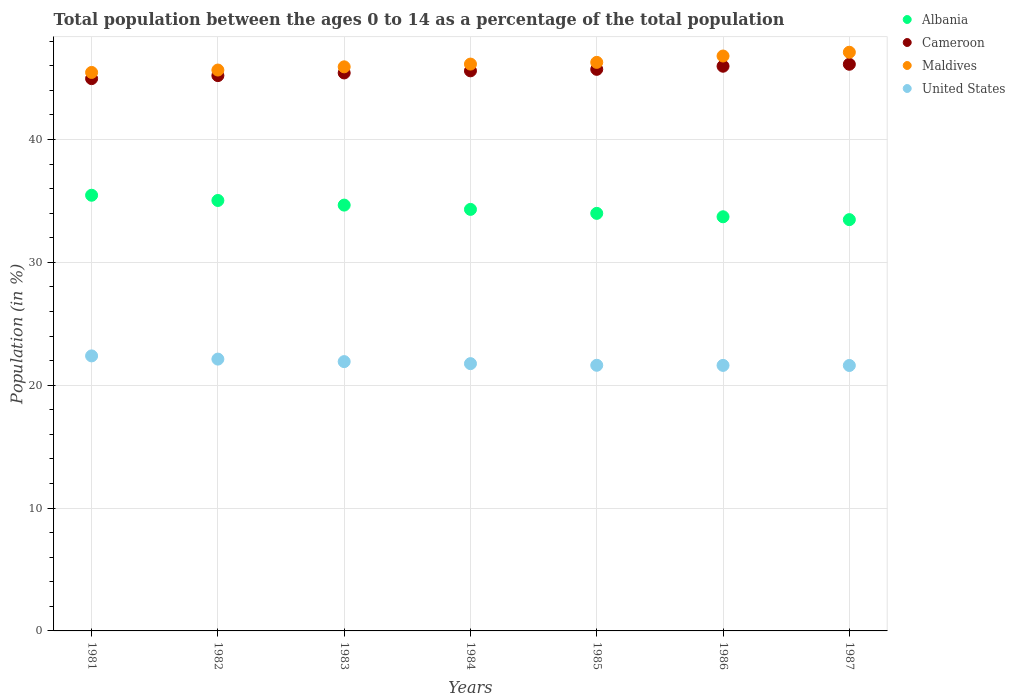Is the number of dotlines equal to the number of legend labels?
Your answer should be compact. Yes. What is the percentage of the population ages 0 to 14 in Maldives in 1986?
Make the answer very short. 46.79. Across all years, what is the maximum percentage of the population ages 0 to 14 in Albania?
Keep it short and to the point. 35.46. Across all years, what is the minimum percentage of the population ages 0 to 14 in United States?
Your answer should be very brief. 21.61. In which year was the percentage of the population ages 0 to 14 in Maldives maximum?
Make the answer very short. 1987. In which year was the percentage of the population ages 0 to 14 in Cameroon minimum?
Your answer should be very brief. 1981. What is the total percentage of the population ages 0 to 14 in Albania in the graph?
Make the answer very short. 240.64. What is the difference between the percentage of the population ages 0 to 14 in Maldives in 1981 and that in 1982?
Ensure brevity in your answer.  -0.2. What is the difference between the percentage of the population ages 0 to 14 in Cameroon in 1984 and the percentage of the population ages 0 to 14 in Maldives in 1986?
Keep it short and to the point. -1.21. What is the average percentage of the population ages 0 to 14 in Cameroon per year?
Your answer should be very brief. 45.57. In the year 1983, what is the difference between the percentage of the population ages 0 to 14 in United States and percentage of the population ages 0 to 14 in Cameroon?
Your response must be concise. -23.5. What is the ratio of the percentage of the population ages 0 to 14 in United States in 1983 to that in 1984?
Your answer should be compact. 1.01. Is the percentage of the population ages 0 to 14 in Maldives in 1983 less than that in 1986?
Give a very brief answer. Yes. What is the difference between the highest and the second highest percentage of the population ages 0 to 14 in United States?
Provide a short and direct response. 0.26. What is the difference between the highest and the lowest percentage of the population ages 0 to 14 in Albania?
Your response must be concise. 1.99. Is it the case that in every year, the sum of the percentage of the population ages 0 to 14 in Maldives and percentage of the population ages 0 to 14 in Albania  is greater than the percentage of the population ages 0 to 14 in Cameroon?
Your answer should be compact. Yes. Is the percentage of the population ages 0 to 14 in Albania strictly greater than the percentage of the population ages 0 to 14 in Maldives over the years?
Your answer should be compact. No. How many dotlines are there?
Provide a short and direct response. 4. How many years are there in the graph?
Provide a succinct answer. 7. What is the difference between two consecutive major ticks on the Y-axis?
Provide a succinct answer. 10. Does the graph contain any zero values?
Keep it short and to the point. No. Does the graph contain grids?
Make the answer very short. Yes. How are the legend labels stacked?
Your answer should be very brief. Vertical. What is the title of the graph?
Ensure brevity in your answer.  Total population between the ages 0 to 14 as a percentage of the total population. What is the label or title of the Y-axis?
Ensure brevity in your answer.  Population (in %). What is the Population (in %) in Albania in 1981?
Provide a short and direct response. 35.46. What is the Population (in %) of Cameroon in 1981?
Ensure brevity in your answer.  44.95. What is the Population (in %) of Maldives in 1981?
Provide a short and direct response. 45.46. What is the Population (in %) in United States in 1981?
Your answer should be very brief. 22.39. What is the Population (in %) in Albania in 1982?
Ensure brevity in your answer.  35.04. What is the Population (in %) of Cameroon in 1982?
Ensure brevity in your answer.  45.2. What is the Population (in %) in Maldives in 1982?
Give a very brief answer. 45.65. What is the Population (in %) in United States in 1982?
Make the answer very short. 22.13. What is the Population (in %) in Albania in 1983?
Offer a very short reply. 34.66. What is the Population (in %) in Cameroon in 1983?
Keep it short and to the point. 45.42. What is the Population (in %) in Maldives in 1983?
Keep it short and to the point. 45.92. What is the Population (in %) in United States in 1983?
Ensure brevity in your answer.  21.92. What is the Population (in %) in Albania in 1984?
Provide a succinct answer. 34.31. What is the Population (in %) in Cameroon in 1984?
Provide a short and direct response. 45.59. What is the Population (in %) in Maldives in 1984?
Your answer should be very brief. 46.14. What is the Population (in %) of United States in 1984?
Give a very brief answer. 21.76. What is the Population (in %) in Albania in 1985?
Provide a succinct answer. 33.99. What is the Population (in %) of Cameroon in 1985?
Your answer should be compact. 45.71. What is the Population (in %) of Maldives in 1985?
Your answer should be very brief. 46.28. What is the Population (in %) of United States in 1985?
Make the answer very short. 21.62. What is the Population (in %) in Albania in 1986?
Provide a succinct answer. 33.71. What is the Population (in %) of Cameroon in 1986?
Provide a succinct answer. 45.96. What is the Population (in %) in Maldives in 1986?
Provide a succinct answer. 46.79. What is the Population (in %) in United States in 1986?
Your answer should be very brief. 21.61. What is the Population (in %) in Albania in 1987?
Keep it short and to the point. 33.48. What is the Population (in %) of Cameroon in 1987?
Your response must be concise. 46.12. What is the Population (in %) in Maldives in 1987?
Your response must be concise. 47.1. What is the Population (in %) of United States in 1987?
Provide a short and direct response. 21.61. Across all years, what is the maximum Population (in %) in Albania?
Provide a succinct answer. 35.46. Across all years, what is the maximum Population (in %) of Cameroon?
Give a very brief answer. 46.12. Across all years, what is the maximum Population (in %) in Maldives?
Make the answer very short. 47.1. Across all years, what is the maximum Population (in %) in United States?
Your answer should be compact. 22.39. Across all years, what is the minimum Population (in %) of Albania?
Keep it short and to the point. 33.48. Across all years, what is the minimum Population (in %) of Cameroon?
Keep it short and to the point. 44.95. Across all years, what is the minimum Population (in %) of Maldives?
Keep it short and to the point. 45.46. Across all years, what is the minimum Population (in %) in United States?
Your answer should be very brief. 21.61. What is the total Population (in %) of Albania in the graph?
Offer a very short reply. 240.64. What is the total Population (in %) of Cameroon in the graph?
Your answer should be very brief. 318.96. What is the total Population (in %) in Maldives in the graph?
Ensure brevity in your answer.  323.34. What is the total Population (in %) of United States in the graph?
Give a very brief answer. 153.03. What is the difference between the Population (in %) in Albania in 1981 and that in 1982?
Keep it short and to the point. 0.43. What is the difference between the Population (in %) of Cameroon in 1981 and that in 1982?
Give a very brief answer. -0.25. What is the difference between the Population (in %) of Maldives in 1981 and that in 1982?
Provide a short and direct response. -0.2. What is the difference between the Population (in %) of United States in 1981 and that in 1982?
Offer a very short reply. 0.26. What is the difference between the Population (in %) in Albania in 1981 and that in 1983?
Give a very brief answer. 0.8. What is the difference between the Population (in %) in Cameroon in 1981 and that in 1983?
Make the answer very short. -0.46. What is the difference between the Population (in %) of Maldives in 1981 and that in 1983?
Your response must be concise. -0.46. What is the difference between the Population (in %) in United States in 1981 and that in 1983?
Offer a very short reply. 0.47. What is the difference between the Population (in %) of Albania in 1981 and that in 1984?
Your answer should be compact. 1.15. What is the difference between the Population (in %) of Cameroon in 1981 and that in 1984?
Ensure brevity in your answer.  -0.63. What is the difference between the Population (in %) of Maldives in 1981 and that in 1984?
Make the answer very short. -0.68. What is the difference between the Population (in %) in United States in 1981 and that in 1984?
Offer a terse response. 0.63. What is the difference between the Population (in %) of Albania in 1981 and that in 1985?
Your response must be concise. 1.47. What is the difference between the Population (in %) of Cameroon in 1981 and that in 1985?
Your answer should be compact. -0.76. What is the difference between the Population (in %) in Maldives in 1981 and that in 1985?
Give a very brief answer. -0.82. What is the difference between the Population (in %) in United States in 1981 and that in 1985?
Your answer should be compact. 0.76. What is the difference between the Population (in %) in Albania in 1981 and that in 1986?
Offer a terse response. 1.75. What is the difference between the Population (in %) of Cameroon in 1981 and that in 1986?
Keep it short and to the point. -1.01. What is the difference between the Population (in %) in Maldives in 1981 and that in 1986?
Your answer should be compact. -1.34. What is the difference between the Population (in %) of United States in 1981 and that in 1986?
Offer a very short reply. 0.77. What is the difference between the Population (in %) in Albania in 1981 and that in 1987?
Offer a terse response. 1.99. What is the difference between the Population (in %) of Cameroon in 1981 and that in 1987?
Offer a terse response. -1.17. What is the difference between the Population (in %) of Maldives in 1981 and that in 1987?
Your answer should be compact. -1.64. What is the difference between the Population (in %) of United States in 1981 and that in 1987?
Ensure brevity in your answer.  0.78. What is the difference between the Population (in %) of Albania in 1982 and that in 1983?
Your answer should be compact. 0.38. What is the difference between the Population (in %) of Cameroon in 1982 and that in 1983?
Keep it short and to the point. -0.22. What is the difference between the Population (in %) of Maldives in 1982 and that in 1983?
Make the answer very short. -0.26. What is the difference between the Population (in %) in United States in 1982 and that in 1983?
Make the answer very short. 0.2. What is the difference between the Population (in %) of Albania in 1982 and that in 1984?
Offer a very short reply. 0.73. What is the difference between the Population (in %) of Cameroon in 1982 and that in 1984?
Provide a succinct answer. -0.39. What is the difference between the Population (in %) of Maldives in 1982 and that in 1984?
Provide a short and direct response. -0.48. What is the difference between the Population (in %) of United States in 1982 and that in 1984?
Provide a short and direct response. 0.37. What is the difference between the Population (in %) of Albania in 1982 and that in 1985?
Offer a very short reply. 1.05. What is the difference between the Population (in %) in Cameroon in 1982 and that in 1985?
Your answer should be very brief. -0.51. What is the difference between the Population (in %) of Maldives in 1982 and that in 1985?
Your response must be concise. -0.63. What is the difference between the Population (in %) of United States in 1982 and that in 1985?
Your answer should be very brief. 0.5. What is the difference between the Population (in %) in Albania in 1982 and that in 1986?
Make the answer very short. 1.33. What is the difference between the Population (in %) in Cameroon in 1982 and that in 1986?
Offer a terse response. -0.76. What is the difference between the Population (in %) of Maldives in 1982 and that in 1986?
Ensure brevity in your answer.  -1.14. What is the difference between the Population (in %) in United States in 1982 and that in 1986?
Provide a succinct answer. 0.51. What is the difference between the Population (in %) of Albania in 1982 and that in 1987?
Ensure brevity in your answer.  1.56. What is the difference between the Population (in %) in Cameroon in 1982 and that in 1987?
Offer a very short reply. -0.92. What is the difference between the Population (in %) of Maldives in 1982 and that in 1987?
Provide a succinct answer. -1.45. What is the difference between the Population (in %) of United States in 1982 and that in 1987?
Your response must be concise. 0.52. What is the difference between the Population (in %) of Albania in 1983 and that in 1984?
Your answer should be compact. 0.35. What is the difference between the Population (in %) of Cameroon in 1983 and that in 1984?
Provide a short and direct response. -0.17. What is the difference between the Population (in %) in Maldives in 1983 and that in 1984?
Ensure brevity in your answer.  -0.22. What is the difference between the Population (in %) of United States in 1983 and that in 1984?
Provide a short and direct response. 0.16. What is the difference between the Population (in %) in Albania in 1983 and that in 1985?
Keep it short and to the point. 0.67. What is the difference between the Population (in %) in Cameroon in 1983 and that in 1985?
Offer a terse response. -0.29. What is the difference between the Population (in %) of Maldives in 1983 and that in 1985?
Ensure brevity in your answer.  -0.36. What is the difference between the Population (in %) in United States in 1983 and that in 1985?
Offer a terse response. 0.3. What is the difference between the Population (in %) in Albania in 1983 and that in 1986?
Your answer should be compact. 0.95. What is the difference between the Population (in %) of Cameroon in 1983 and that in 1986?
Your response must be concise. -0.55. What is the difference between the Population (in %) in Maldives in 1983 and that in 1986?
Offer a terse response. -0.88. What is the difference between the Population (in %) in United States in 1983 and that in 1986?
Keep it short and to the point. 0.31. What is the difference between the Population (in %) in Albania in 1983 and that in 1987?
Give a very brief answer. 1.18. What is the difference between the Population (in %) in Cameroon in 1983 and that in 1987?
Your answer should be compact. -0.71. What is the difference between the Population (in %) of Maldives in 1983 and that in 1987?
Make the answer very short. -1.19. What is the difference between the Population (in %) of United States in 1983 and that in 1987?
Provide a short and direct response. 0.31. What is the difference between the Population (in %) in Albania in 1984 and that in 1985?
Offer a very short reply. 0.32. What is the difference between the Population (in %) of Cameroon in 1984 and that in 1985?
Your answer should be very brief. -0.12. What is the difference between the Population (in %) of Maldives in 1984 and that in 1985?
Your response must be concise. -0.14. What is the difference between the Population (in %) of United States in 1984 and that in 1985?
Keep it short and to the point. 0.13. What is the difference between the Population (in %) in Albania in 1984 and that in 1986?
Ensure brevity in your answer.  0.6. What is the difference between the Population (in %) in Cameroon in 1984 and that in 1986?
Your answer should be compact. -0.38. What is the difference between the Population (in %) of Maldives in 1984 and that in 1986?
Give a very brief answer. -0.66. What is the difference between the Population (in %) of United States in 1984 and that in 1986?
Your response must be concise. 0.14. What is the difference between the Population (in %) of Albania in 1984 and that in 1987?
Your response must be concise. 0.83. What is the difference between the Population (in %) in Cameroon in 1984 and that in 1987?
Keep it short and to the point. -0.54. What is the difference between the Population (in %) of Maldives in 1984 and that in 1987?
Offer a terse response. -0.96. What is the difference between the Population (in %) of United States in 1984 and that in 1987?
Offer a terse response. 0.15. What is the difference between the Population (in %) of Albania in 1985 and that in 1986?
Your answer should be compact. 0.28. What is the difference between the Population (in %) in Cameroon in 1985 and that in 1986?
Offer a terse response. -0.25. What is the difference between the Population (in %) in Maldives in 1985 and that in 1986?
Your answer should be compact. -0.52. What is the difference between the Population (in %) of United States in 1985 and that in 1986?
Your answer should be very brief. 0.01. What is the difference between the Population (in %) of Albania in 1985 and that in 1987?
Give a very brief answer. 0.51. What is the difference between the Population (in %) of Cameroon in 1985 and that in 1987?
Your answer should be very brief. -0.41. What is the difference between the Population (in %) in Maldives in 1985 and that in 1987?
Your answer should be compact. -0.82. What is the difference between the Population (in %) in United States in 1985 and that in 1987?
Provide a succinct answer. 0.02. What is the difference between the Population (in %) of Albania in 1986 and that in 1987?
Offer a very short reply. 0.23. What is the difference between the Population (in %) in Cameroon in 1986 and that in 1987?
Offer a very short reply. -0.16. What is the difference between the Population (in %) of Maldives in 1986 and that in 1987?
Offer a very short reply. -0.31. What is the difference between the Population (in %) of United States in 1986 and that in 1987?
Keep it short and to the point. 0.01. What is the difference between the Population (in %) of Albania in 1981 and the Population (in %) of Cameroon in 1982?
Offer a very short reply. -9.74. What is the difference between the Population (in %) in Albania in 1981 and the Population (in %) in Maldives in 1982?
Give a very brief answer. -10.19. What is the difference between the Population (in %) in Albania in 1981 and the Population (in %) in United States in 1982?
Your response must be concise. 13.34. What is the difference between the Population (in %) in Cameroon in 1981 and the Population (in %) in Maldives in 1982?
Your answer should be compact. -0.7. What is the difference between the Population (in %) of Cameroon in 1981 and the Population (in %) of United States in 1982?
Your answer should be compact. 22.83. What is the difference between the Population (in %) in Maldives in 1981 and the Population (in %) in United States in 1982?
Offer a very short reply. 23.33. What is the difference between the Population (in %) in Albania in 1981 and the Population (in %) in Cameroon in 1983?
Provide a short and direct response. -9.95. What is the difference between the Population (in %) in Albania in 1981 and the Population (in %) in Maldives in 1983?
Provide a succinct answer. -10.45. What is the difference between the Population (in %) in Albania in 1981 and the Population (in %) in United States in 1983?
Keep it short and to the point. 13.54. What is the difference between the Population (in %) in Cameroon in 1981 and the Population (in %) in Maldives in 1983?
Offer a terse response. -0.96. What is the difference between the Population (in %) in Cameroon in 1981 and the Population (in %) in United States in 1983?
Offer a terse response. 23.03. What is the difference between the Population (in %) of Maldives in 1981 and the Population (in %) of United States in 1983?
Provide a succinct answer. 23.54. What is the difference between the Population (in %) in Albania in 1981 and the Population (in %) in Cameroon in 1984?
Give a very brief answer. -10.13. What is the difference between the Population (in %) in Albania in 1981 and the Population (in %) in Maldives in 1984?
Offer a very short reply. -10.68. What is the difference between the Population (in %) in Albania in 1981 and the Population (in %) in United States in 1984?
Give a very brief answer. 13.71. What is the difference between the Population (in %) of Cameroon in 1981 and the Population (in %) of Maldives in 1984?
Provide a succinct answer. -1.18. What is the difference between the Population (in %) of Cameroon in 1981 and the Population (in %) of United States in 1984?
Your answer should be compact. 23.2. What is the difference between the Population (in %) of Maldives in 1981 and the Population (in %) of United States in 1984?
Keep it short and to the point. 23.7. What is the difference between the Population (in %) in Albania in 1981 and the Population (in %) in Cameroon in 1985?
Provide a succinct answer. -10.25. What is the difference between the Population (in %) of Albania in 1981 and the Population (in %) of Maldives in 1985?
Your response must be concise. -10.82. What is the difference between the Population (in %) in Albania in 1981 and the Population (in %) in United States in 1985?
Provide a succinct answer. 13.84. What is the difference between the Population (in %) of Cameroon in 1981 and the Population (in %) of Maldives in 1985?
Offer a terse response. -1.32. What is the difference between the Population (in %) of Cameroon in 1981 and the Population (in %) of United States in 1985?
Provide a succinct answer. 23.33. What is the difference between the Population (in %) in Maldives in 1981 and the Population (in %) in United States in 1985?
Ensure brevity in your answer.  23.84. What is the difference between the Population (in %) in Albania in 1981 and the Population (in %) in Cameroon in 1986?
Offer a terse response. -10.5. What is the difference between the Population (in %) of Albania in 1981 and the Population (in %) of Maldives in 1986?
Offer a very short reply. -11.33. What is the difference between the Population (in %) of Albania in 1981 and the Population (in %) of United States in 1986?
Ensure brevity in your answer.  13.85. What is the difference between the Population (in %) in Cameroon in 1981 and the Population (in %) in Maldives in 1986?
Offer a very short reply. -1.84. What is the difference between the Population (in %) of Cameroon in 1981 and the Population (in %) of United States in 1986?
Provide a succinct answer. 23.34. What is the difference between the Population (in %) in Maldives in 1981 and the Population (in %) in United States in 1986?
Your response must be concise. 23.85. What is the difference between the Population (in %) of Albania in 1981 and the Population (in %) of Cameroon in 1987?
Make the answer very short. -10.66. What is the difference between the Population (in %) in Albania in 1981 and the Population (in %) in Maldives in 1987?
Your response must be concise. -11.64. What is the difference between the Population (in %) of Albania in 1981 and the Population (in %) of United States in 1987?
Your answer should be compact. 13.86. What is the difference between the Population (in %) in Cameroon in 1981 and the Population (in %) in Maldives in 1987?
Make the answer very short. -2.15. What is the difference between the Population (in %) of Cameroon in 1981 and the Population (in %) of United States in 1987?
Keep it short and to the point. 23.35. What is the difference between the Population (in %) in Maldives in 1981 and the Population (in %) in United States in 1987?
Give a very brief answer. 23.85. What is the difference between the Population (in %) in Albania in 1982 and the Population (in %) in Cameroon in 1983?
Provide a short and direct response. -10.38. What is the difference between the Population (in %) of Albania in 1982 and the Population (in %) of Maldives in 1983?
Give a very brief answer. -10.88. What is the difference between the Population (in %) in Albania in 1982 and the Population (in %) in United States in 1983?
Provide a short and direct response. 13.12. What is the difference between the Population (in %) of Cameroon in 1982 and the Population (in %) of Maldives in 1983?
Offer a terse response. -0.71. What is the difference between the Population (in %) of Cameroon in 1982 and the Population (in %) of United States in 1983?
Ensure brevity in your answer.  23.28. What is the difference between the Population (in %) in Maldives in 1982 and the Population (in %) in United States in 1983?
Provide a succinct answer. 23.73. What is the difference between the Population (in %) in Albania in 1982 and the Population (in %) in Cameroon in 1984?
Provide a short and direct response. -10.55. What is the difference between the Population (in %) in Albania in 1982 and the Population (in %) in Maldives in 1984?
Offer a very short reply. -11.1. What is the difference between the Population (in %) of Albania in 1982 and the Population (in %) of United States in 1984?
Provide a succinct answer. 13.28. What is the difference between the Population (in %) in Cameroon in 1982 and the Population (in %) in Maldives in 1984?
Provide a short and direct response. -0.94. What is the difference between the Population (in %) in Cameroon in 1982 and the Population (in %) in United States in 1984?
Provide a succinct answer. 23.44. What is the difference between the Population (in %) of Maldives in 1982 and the Population (in %) of United States in 1984?
Make the answer very short. 23.9. What is the difference between the Population (in %) of Albania in 1982 and the Population (in %) of Cameroon in 1985?
Your response must be concise. -10.67. What is the difference between the Population (in %) in Albania in 1982 and the Population (in %) in Maldives in 1985?
Your response must be concise. -11.24. What is the difference between the Population (in %) in Albania in 1982 and the Population (in %) in United States in 1985?
Provide a succinct answer. 13.41. What is the difference between the Population (in %) in Cameroon in 1982 and the Population (in %) in Maldives in 1985?
Your answer should be compact. -1.08. What is the difference between the Population (in %) of Cameroon in 1982 and the Population (in %) of United States in 1985?
Provide a short and direct response. 23.58. What is the difference between the Population (in %) of Maldives in 1982 and the Population (in %) of United States in 1985?
Offer a very short reply. 24.03. What is the difference between the Population (in %) of Albania in 1982 and the Population (in %) of Cameroon in 1986?
Offer a terse response. -10.93. What is the difference between the Population (in %) of Albania in 1982 and the Population (in %) of Maldives in 1986?
Your response must be concise. -11.76. What is the difference between the Population (in %) of Albania in 1982 and the Population (in %) of United States in 1986?
Ensure brevity in your answer.  13.42. What is the difference between the Population (in %) in Cameroon in 1982 and the Population (in %) in Maldives in 1986?
Offer a terse response. -1.59. What is the difference between the Population (in %) of Cameroon in 1982 and the Population (in %) of United States in 1986?
Keep it short and to the point. 23.59. What is the difference between the Population (in %) of Maldives in 1982 and the Population (in %) of United States in 1986?
Offer a very short reply. 24.04. What is the difference between the Population (in %) in Albania in 1982 and the Population (in %) in Cameroon in 1987?
Ensure brevity in your answer.  -11.09. What is the difference between the Population (in %) of Albania in 1982 and the Population (in %) of Maldives in 1987?
Make the answer very short. -12.07. What is the difference between the Population (in %) in Albania in 1982 and the Population (in %) in United States in 1987?
Your answer should be compact. 13.43. What is the difference between the Population (in %) of Cameroon in 1982 and the Population (in %) of Maldives in 1987?
Your answer should be compact. -1.9. What is the difference between the Population (in %) in Cameroon in 1982 and the Population (in %) in United States in 1987?
Offer a very short reply. 23.59. What is the difference between the Population (in %) of Maldives in 1982 and the Population (in %) of United States in 1987?
Your answer should be compact. 24.05. What is the difference between the Population (in %) of Albania in 1983 and the Population (in %) of Cameroon in 1984?
Provide a short and direct response. -10.93. What is the difference between the Population (in %) in Albania in 1983 and the Population (in %) in Maldives in 1984?
Provide a short and direct response. -11.48. What is the difference between the Population (in %) in Albania in 1983 and the Population (in %) in United States in 1984?
Give a very brief answer. 12.9. What is the difference between the Population (in %) of Cameroon in 1983 and the Population (in %) of Maldives in 1984?
Make the answer very short. -0.72. What is the difference between the Population (in %) in Cameroon in 1983 and the Population (in %) in United States in 1984?
Ensure brevity in your answer.  23.66. What is the difference between the Population (in %) in Maldives in 1983 and the Population (in %) in United States in 1984?
Keep it short and to the point. 24.16. What is the difference between the Population (in %) in Albania in 1983 and the Population (in %) in Cameroon in 1985?
Offer a very short reply. -11.05. What is the difference between the Population (in %) in Albania in 1983 and the Population (in %) in Maldives in 1985?
Provide a succinct answer. -11.62. What is the difference between the Population (in %) of Albania in 1983 and the Population (in %) of United States in 1985?
Your response must be concise. 13.04. What is the difference between the Population (in %) of Cameroon in 1983 and the Population (in %) of Maldives in 1985?
Your answer should be compact. -0.86. What is the difference between the Population (in %) in Cameroon in 1983 and the Population (in %) in United States in 1985?
Provide a short and direct response. 23.79. What is the difference between the Population (in %) in Maldives in 1983 and the Population (in %) in United States in 1985?
Offer a terse response. 24.29. What is the difference between the Population (in %) in Albania in 1983 and the Population (in %) in Cameroon in 1986?
Give a very brief answer. -11.3. What is the difference between the Population (in %) in Albania in 1983 and the Population (in %) in Maldives in 1986?
Offer a very short reply. -12.13. What is the difference between the Population (in %) of Albania in 1983 and the Population (in %) of United States in 1986?
Make the answer very short. 13.05. What is the difference between the Population (in %) in Cameroon in 1983 and the Population (in %) in Maldives in 1986?
Ensure brevity in your answer.  -1.38. What is the difference between the Population (in %) of Cameroon in 1983 and the Population (in %) of United States in 1986?
Give a very brief answer. 23.8. What is the difference between the Population (in %) of Maldives in 1983 and the Population (in %) of United States in 1986?
Keep it short and to the point. 24.3. What is the difference between the Population (in %) of Albania in 1983 and the Population (in %) of Cameroon in 1987?
Provide a succinct answer. -11.46. What is the difference between the Population (in %) of Albania in 1983 and the Population (in %) of Maldives in 1987?
Make the answer very short. -12.44. What is the difference between the Population (in %) of Albania in 1983 and the Population (in %) of United States in 1987?
Your answer should be compact. 13.05. What is the difference between the Population (in %) in Cameroon in 1983 and the Population (in %) in Maldives in 1987?
Provide a succinct answer. -1.69. What is the difference between the Population (in %) in Cameroon in 1983 and the Population (in %) in United States in 1987?
Ensure brevity in your answer.  23.81. What is the difference between the Population (in %) of Maldives in 1983 and the Population (in %) of United States in 1987?
Provide a succinct answer. 24.31. What is the difference between the Population (in %) in Albania in 1984 and the Population (in %) in Cameroon in 1985?
Your response must be concise. -11.4. What is the difference between the Population (in %) of Albania in 1984 and the Population (in %) of Maldives in 1985?
Your answer should be compact. -11.97. What is the difference between the Population (in %) in Albania in 1984 and the Population (in %) in United States in 1985?
Give a very brief answer. 12.69. What is the difference between the Population (in %) in Cameroon in 1984 and the Population (in %) in Maldives in 1985?
Ensure brevity in your answer.  -0.69. What is the difference between the Population (in %) of Cameroon in 1984 and the Population (in %) of United States in 1985?
Your response must be concise. 23.97. What is the difference between the Population (in %) in Maldives in 1984 and the Population (in %) in United States in 1985?
Ensure brevity in your answer.  24.52. What is the difference between the Population (in %) in Albania in 1984 and the Population (in %) in Cameroon in 1986?
Your answer should be very brief. -11.65. What is the difference between the Population (in %) of Albania in 1984 and the Population (in %) of Maldives in 1986?
Ensure brevity in your answer.  -12.48. What is the difference between the Population (in %) in Albania in 1984 and the Population (in %) in United States in 1986?
Make the answer very short. 12.7. What is the difference between the Population (in %) in Cameroon in 1984 and the Population (in %) in Maldives in 1986?
Provide a succinct answer. -1.21. What is the difference between the Population (in %) in Cameroon in 1984 and the Population (in %) in United States in 1986?
Keep it short and to the point. 23.98. What is the difference between the Population (in %) of Maldives in 1984 and the Population (in %) of United States in 1986?
Give a very brief answer. 24.52. What is the difference between the Population (in %) of Albania in 1984 and the Population (in %) of Cameroon in 1987?
Your answer should be very brief. -11.81. What is the difference between the Population (in %) of Albania in 1984 and the Population (in %) of Maldives in 1987?
Your answer should be compact. -12.79. What is the difference between the Population (in %) in Albania in 1984 and the Population (in %) in United States in 1987?
Give a very brief answer. 12.7. What is the difference between the Population (in %) of Cameroon in 1984 and the Population (in %) of Maldives in 1987?
Provide a succinct answer. -1.51. What is the difference between the Population (in %) of Cameroon in 1984 and the Population (in %) of United States in 1987?
Provide a short and direct response. 23.98. What is the difference between the Population (in %) in Maldives in 1984 and the Population (in %) in United States in 1987?
Your answer should be compact. 24.53. What is the difference between the Population (in %) of Albania in 1985 and the Population (in %) of Cameroon in 1986?
Make the answer very short. -11.98. What is the difference between the Population (in %) in Albania in 1985 and the Population (in %) in Maldives in 1986?
Your answer should be compact. -12.81. What is the difference between the Population (in %) in Albania in 1985 and the Population (in %) in United States in 1986?
Offer a very short reply. 12.37. What is the difference between the Population (in %) of Cameroon in 1985 and the Population (in %) of Maldives in 1986?
Your answer should be very brief. -1.08. What is the difference between the Population (in %) in Cameroon in 1985 and the Population (in %) in United States in 1986?
Offer a terse response. 24.1. What is the difference between the Population (in %) in Maldives in 1985 and the Population (in %) in United States in 1986?
Make the answer very short. 24.67. What is the difference between the Population (in %) of Albania in 1985 and the Population (in %) of Cameroon in 1987?
Offer a terse response. -12.14. What is the difference between the Population (in %) in Albania in 1985 and the Population (in %) in Maldives in 1987?
Offer a very short reply. -13.12. What is the difference between the Population (in %) in Albania in 1985 and the Population (in %) in United States in 1987?
Keep it short and to the point. 12.38. What is the difference between the Population (in %) of Cameroon in 1985 and the Population (in %) of Maldives in 1987?
Ensure brevity in your answer.  -1.39. What is the difference between the Population (in %) in Cameroon in 1985 and the Population (in %) in United States in 1987?
Provide a short and direct response. 24.1. What is the difference between the Population (in %) of Maldives in 1985 and the Population (in %) of United States in 1987?
Your answer should be compact. 24.67. What is the difference between the Population (in %) of Albania in 1986 and the Population (in %) of Cameroon in 1987?
Keep it short and to the point. -12.41. What is the difference between the Population (in %) in Albania in 1986 and the Population (in %) in Maldives in 1987?
Ensure brevity in your answer.  -13.39. What is the difference between the Population (in %) in Albania in 1986 and the Population (in %) in United States in 1987?
Your answer should be compact. 12.1. What is the difference between the Population (in %) of Cameroon in 1986 and the Population (in %) of Maldives in 1987?
Offer a terse response. -1.14. What is the difference between the Population (in %) of Cameroon in 1986 and the Population (in %) of United States in 1987?
Offer a terse response. 24.36. What is the difference between the Population (in %) of Maldives in 1986 and the Population (in %) of United States in 1987?
Your answer should be very brief. 25.19. What is the average Population (in %) of Albania per year?
Make the answer very short. 34.38. What is the average Population (in %) of Cameroon per year?
Ensure brevity in your answer.  45.57. What is the average Population (in %) of Maldives per year?
Your answer should be compact. 46.19. What is the average Population (in %) of United States per year?
Provide a short and direct response. 21.86. In the year 1981, what is the difference between the Population (in %) in Albania and Population (in %) in Cameroon?
Offer a terse response. -9.49. In the year 1981, what is the difference between the Population (in %) in Albania and Population (in %) in Maldives?
Offer a very short reply. -10. In the year 1981, what is the difference between the Population (in %) in Albania and Population (in %) in United States?
Your answer should be very brief. 13.08. In the year 1981, what is the difference between the Population (in %) in Cameroon and Population (in %) in Maldives?
Give a very brief answer. -0.5. In the year 1981, what is the difference between the Population (in %) in Cameroon and Population (in %) in United States?
Offer a terse response. 22.57. In the year 1981, what is the difference between the Population (in %) of Maldives and Population (in %) of United States?
Offer a very short reply. 23.07. In the year 1982, what is the difference between the Population (in %) of Albania and Population (in %) of Cameroon?
Your answer should be very brief. -10.16. In the year 1982, what is the difference between the Population (in %) of Albania and Population (in %) of Maldives?
Your response must be concise. -10.62. In the year 1982, what is the difference between the Population (in %) of Albania and Population (in %) of United States?
Ensure brevity in your answer.  12.91. In the year 1982, what is the difference between the Population (in %) in Cameroon and Population (in %) in Maldives?
Your answer should be compact. -0.45. In the year 1982, what is the difference between the Population (in %) of Cameroon and Population (in %) of United States?
Your answer should be very brief. 23.08. In the year 1982, what is the difference between the Population (in %) of Maldives and Population (in %) of United States?
Offer a very short reply. 23.53. In the year 1983, what is the difference between the Population (in %) in Albania and Population (in %) in Cameroon?
Offer a very short reply. -10.76. In the year 1983, what is the difference between the Population (in %) in Albania and Population (in %) in Maldives?
Keep it short and to the point. -11.26. In the year 1983, what is the difference between the Population (in %) of Albania and Population (in %) of United States?
Your response must be concise. 12.74. In the year 1983, what is the difference between the Population (in %) of Cameroon and Population (in %) of Maldives?
Offer a very short reply. -0.5. In the year 1983, what is the difference between the Population (in %) in Cameroon and Population (in %) in United States?
Your response must be concise. 23.5. In the year 1983, what is the difference between the Population (in %) in Maldives and Population (in %) in United States?
Ensure brevity in your answer.  23.99. In the year 1984, what is the difference between the Population (in %) in Albania and Population (in %) in Cameroon?
Your answer should be compact. -11.28. In the year 1984, what is the difference between the Population (in %) in Albania and Population (in %) in Maldives?
Your answer should be compact. -11.83. In the year 1984, what is the difference between the Population (in %) of Albania and Population (in %) of United States?
Keep it short and to the point. 12.56. In the year 1984, what is the difference between the Population (in %) of Cameroon and Population (in %) of Maldives?
Your answer should be compact. -0.55. In the year 1984, what is the difference between the Population (in %) of Cameroon and Population (in %) of United States?
Offer a terse response. 23.83. In the year 1984, what is the difference between the Population (in %) of Maldives and Population (in %) of United States?
Provide a succinct answer. 24.38. In the year 1985, what is the difference between the Population (in %) in Albania and Population (in %) in Cameroon?
Offer a very short reply. -11.72. In the year 1985, what is the difference between the Population (in %) of Albania and Population (in %) of Maldives?
Keep it short and to the point. -12.29. In the year 1985, what is the difference between the Population (in %) in Albania and Population (in %) in United States?
Your answer should be compact. 12.37. In the year 1985, what is the difference between the Population (in %) in Cameroon and Population (in %) in Maldives?
Offer a terse response. -0.57. In the year 1985, what is the difference between the Population (in %) of Cameroon and Population (in %) of United States?
Your response must be concise. 24.09. In the year 1985, what is the difference between the Population (in %) of Maldives and Population (in %) of United States?
Your answer should be very brief. 24.66. In the year 1986, what is the difference between the Population (in %) of Albania and Population (in %) of Cameroon?
Your answer should be compact. -12.25. In the year 1986, what is the difference between the Population (in %) in Albania and Population (in %) in Maldives?
Your answer should be very brief. -13.08. In the year 1986, what is the difference between the Population (in %) in Albania and Population (in %) in United States?
Your answer should be very brief. 12.1. In the year 1986, what is the difference between the Population (in %) of Cameroon and Population (in %) of Maldives?
Provide a succinct answer. -0.83. In the year 1986, what is the difference between the Population (in %) in Cameroon and Population (in %) in United States?
Provide a short and direct response. 24.35. In the year 1986, what is the difference between the Population (in %) of Maldives and Population (in %) of United States?
Your answer should be very brief. 25.18. In the year 1987, what is the difference between the Population (in %) in Albania and Population (in %) in Cameroon?
Keep it short and to the point. -12.65. In the year 1987, what is the difference between the Population (in %) of Albania and Population (in %) of Maldives?
Offer a very short reply. -13.63. In the year 1987, what is the difference between the Population (in %) in Albania and Population (in %) in United States?
Give a very brief answer. 11.87. In the year 1987, what is the difference between the Population (in %) in Cameroon and Population (in %) in Maldives?
Give a very brief answer. -0.98. In the year 1987, what is the difference between the Population (in %) in Cameroon and Population (in %) in United States?
Offer a very short reply. 24.52. In the year 1987, what is the difference between the Population (in %) in Maldives and Population (in %) in United States?
Provide a short and direct response. 25.5. What is the ratio of the Population (in %) of Albania in 1981 to that in 1982?
Offer a very short reply. 1.01. What is the ratio of the Population (in %) of United States in 1981 to that in 1982?
Keep it short and to the point. 1.01. What is the ratio of the Population (in %) in Albania in 1981 to that in 1983?
Ensure brevity in your answer.  1.02. What is the ratio of the Population (in %) in Maldives in 1981 to that in 1983?
Provide a succinct answer. 0.99. What is the ratio of the Population (in %) in United States in 1981 to that in 1983?
Keep it short and to the point. 1.02. What is the ratio of the Population (in %) of Albania in 1981 to that in 1984?
Make the answer very short. 1.03. What is the ratio of the Population (in %) of Cameroon in 1981 to that in 1984?
Provide a succinct answer. 0.99. What is the ratio of the Population (in %) in Maldives in 1981 to that in 1984?
Ensure brevity in your answer.  0.99. What is the ratio of the Population (in %) in United States in 1981 to that in 1984?
Provide a short and direct response. 1.03. What is the ratio of the Population (in %) of Albania in 1981 to that in 1985?
Your response must be concise. 1.04. What is the ratio of the Population (in %) of Cameroon in 1981 to that in 1985?
Give a very brief answer. 0.98. What is the ratio of the Population (in %) in Maldives in 1981 to that in 1985?
Keep it short and to the point. 0.98. What is the ratio of the Population (in %) in United States in 1981 to that in 1985?
Offer a very short reply. 1.04. What is the ratio of the Population (in %) of Albania in 1981 to that in 1986?
Keep it short and to the point. 1.05. What is the ratio of the Population (in %) of Maldives in 1981 to that in 1986?
Provide a short and direct response. 0.97. What is the ratio of the Population (in %) in United States in 1981 to that in 1986?
Offer a very short reply. 1.04. What is the ratio of the Population (in %) of Albania in 1981 to that in 1987?
Your answer should be compact. 1.06. What is the ratio of the Population (in %) of Cameroon in 1981 to that in 1987?
Provide a short and direct response. 0.97. What is the ratio of the Population (in %) in Maldives in 1981 to that in 1987?
Give a very brief answer. 0.97. What is the ratio of the Population (in %) of United States in 1981 to that in 1987?
Provide a short and direct response. 1.04. What is the ratio of the Population (in %) in Albania in 1982 to that in 1983?
Your answer should be very brief. 1.01. What is the ratio of the Population (in %) in Cameroon in 1982 to that in 1983?
Provide a short and direct response. 1. What is the ratio of the Population (in %) in United States in 1982 to that in 1983?
Your answer should be compact. 1.01. What is the ratio of the Population (in %) in Albania in 1982 to that in 1984?
Provide a succinct answer. 1.02. What is the ratio of the Population (in %) of Albania in 1982 to that in 1985?
Your response must be concise. 1.03. What is the ratio of the Population (in %) in Cameroon in 1982 to that in 1985?
Ensure brevity in your answer.  0.99. What is the ratio of the Population (in %) in Maldives in 1982 to that in 1985?
Offer a terse response. 0.99. What is the ratio of the Population (in %) in United States in 1982 to that in 1985?
Your answer should be very brief. 1.02. What is the ratio of the Population (in %) in Albania in 1982 to that in 1986?
Make the answer very short. 1.04. What is the ratio of the Population (in %) in Cameroon in 1982 to that in 1986?
Your response must be concise. 0.98. What is the ratio of the Population (in %) of Maldives in 1982 to that in 1986?
Your response must be concise. 0.98. What is the ratio of the Population (in %) of United States in 1982 to that in 1986?
Your answer should be compact. 1.02. What is the ratio of the Population (in %) of Albania in 1982 to that in 1987?
Ensure brevity in your answer.  1.05. What is the ratio of the Population (in %) in Maldives in 1982 to that in 1987?
Your answer should be compact. 0.97. What is the ratio of the Population (in %) in United States in 1982 to that in 1987?
Your response must be concise. 1.02. What is the ratio of the Population (in %) in Albania in 1983 to that in 1984?
Give a very brief answer. 1.01. What is the ratio of the Population (in %) in Cameroon in 1983 to that in 1984?
Keep it short and to the point. 1. What is the ratio of the Population (in %) of Maldives in 1983 to that in 1984?
Keep it short and to the point. 1. What is the ratio of the Population (in %) of United States in 1983 to that in 1984?
Offer a terse response. 1.01. What is the ratio of the Population (in %) of Albania in 1983 to that in 1985?
Provide a succinct answer. 1.02. What is the ratio of the Population (in %) of United States in 1983 to that in 1985?
Make the answer very short. 1.01. What is the ratio of the Population (in %) in Albania in 1983 to that in 1986?
Offer a terse response. 1.03. What is the ratio of the Population (in %) of Maldives in 1983 to that in 1986?
Give a very brief answer. 0.98. What is the ratio of the Population (in %) in United States in 1983 to that in 1986?
Provide a short and direct response. 1.01. What is the ratio of the Population (in %) of Albania in 1983 to that in 1987?
Offer a terse response. 1.04. What is the ratio of the Population (in %) in Cameroon in 1983 to that in 1987?
Make the answer very short. 0.98. What is the ratio of the Population (in %) of Maldives in 1983 to that in 1987?
Your answer should be compact. 0.97. What is the ratio of the Population (in %) of United States in 1983 to that in 1987?
Provide a short and direct response. 1.01. What is the ratio of the Population (in %) in Albania in 1984 to that in 1985?
Your response must be concise. 1.01. What is the ratio of the Population (in %) of Cameroon in 1984 to that in 1985?
Your response must be concise. 1. What is the ratio of the Population (in %) of Maldives in 1984 to that in 1985?
Ensure brevity in your answer.  1. What is the ratio of the Population (in %) in United States in 1984 to that in 1985?
Give a very brief answer. 1.01. What is the ratio of the Population (in %) in Albania in 1984 to that in 1986?
Make the answer very short. 1.02. What is the ratio of the Population (in %) in United States in 1984 to that in 1986?
Your answer should be compact. 1.01. What is the ratio of the Population (in %) in Albania in 1984 to that in 1987?
Your answer should be very brief. 1.02. What is the ratio of the Population (in %) of Cameroon in 1984 to that in 1987?
Make the answer very short. 0.99. What is the ratio of the Population (in %) in Maldives in 1984 to that in 1987?
Make the answer very short. 0.98. What is the ratio of the Population (in %) of United States in 1984 to that in 1987?
Give a very brief answer. 1.01. What is the ratio of the Population (in %) in Albania in 1985 to that in 1986?
Ensure brevity in your answer.  1.01. What is the ratio of the Population (in %) in Maldives in 1985 to that in 1986?
Provide a succinct answer. 0.99. What is the ratio of the Population (in %) in United States in 1985 to that in 1986?
Ensure brevity in your answer.  1. What is the ratio of the Population (in %) in Albania in 1985 to that in 1987?
Your answer should be very brief. 1.02. What is the ratio of the Population (in %) of Cameroon in 1985 to that in 1987?
Keep it short and to the point. 0.99. What is the ratio of the Population (in %) of Maldives in 1985 to that in 1987?
Make the answer very short. 0.98. What is the ratio of the Population (in %) of United States in 1985 to that in 1987?
Your response must be concise. 1. What is the difference between the highest and the second highest Population (in %) in Albania?
Offer a terse response. 0.43. What is the difference between the highest and the second highest Population (in %) in Cameroon?
Your answer should be very brief. 0.16. What is the difference between the highest and the second highest Population (in %) in Maldives?
Ensure brevity in your answer.  0.31. What is the difference between the highest and the second highest Population (in %) in United States?
Your answer should be very brief. 0.26. What is the difference between the highest and the lowest Population (in %) of Albania?
Keep it short and to the point. 1.99. What is the difference between the highest and the lowest Population (in %) of Cameroon?
Ensure brevity in your answer.  1.17. What is the difference between the highest and the lowest Population (in %) of Maldives?
Offer a terse response. 1.64. What is the difference between the highest and the lowest Population (in %) of United States?
Offer a terse response. 0.78. 